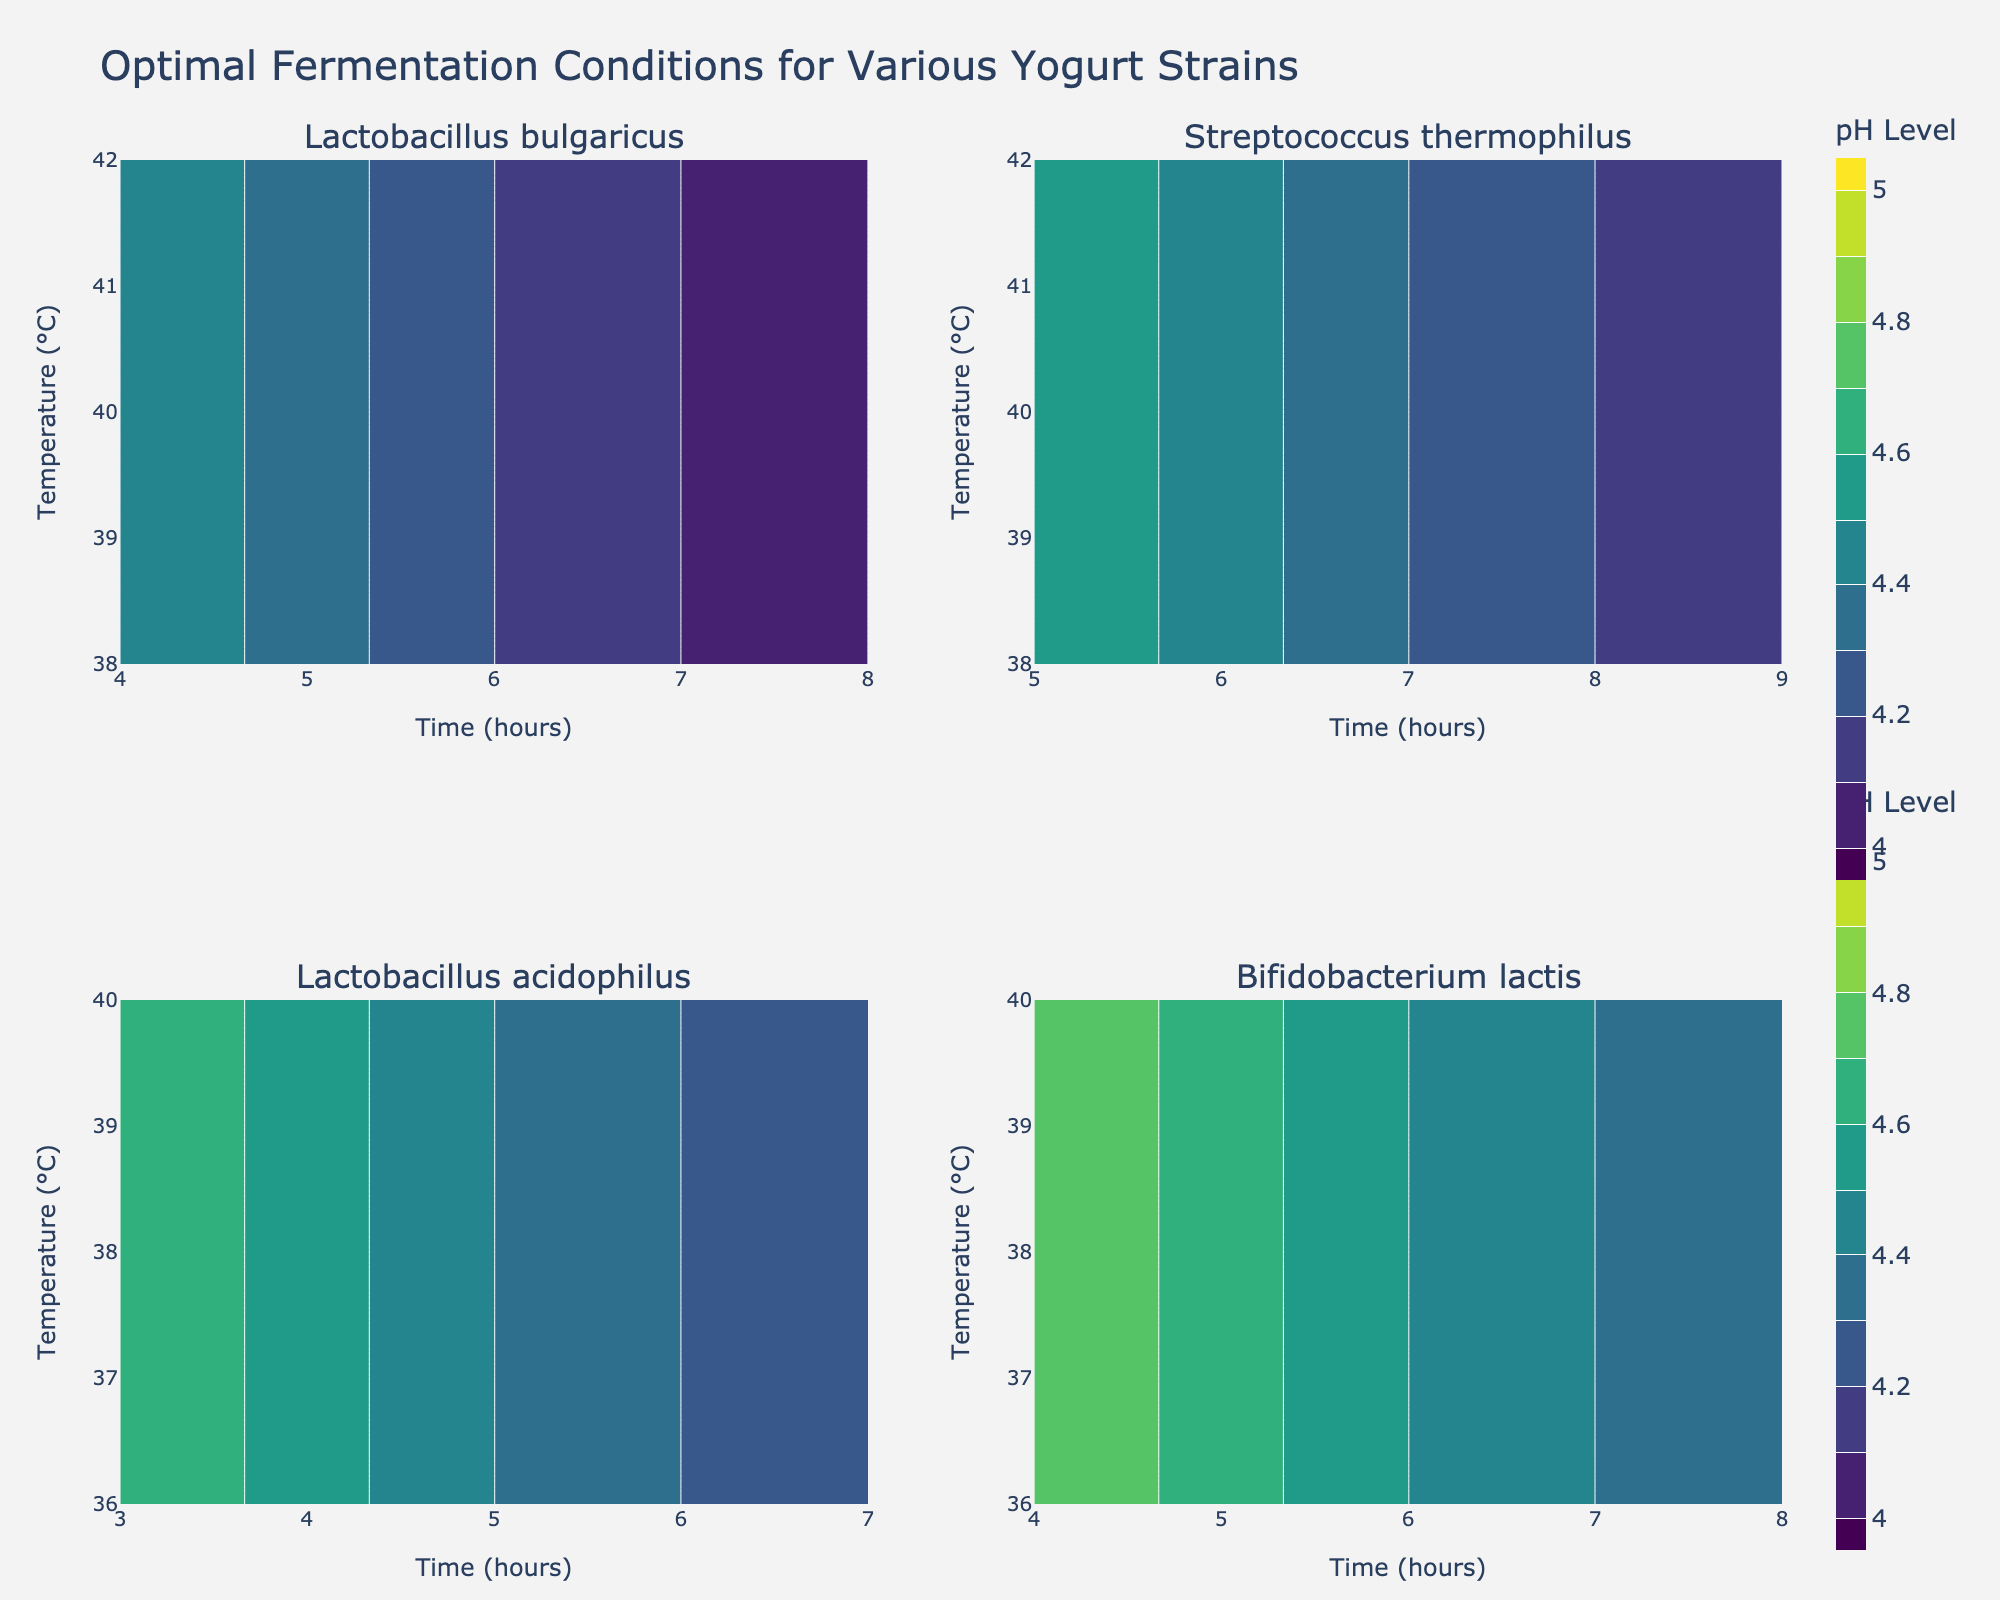What is the title of the figure? The title is displayed at the top center of the figure, indicating the main topic covered by the visualization.
Answer: Optimal Fermentation Conditions for Various Yogurt Strains What are the strains of yogurt shown in the subplots? The strain names can be found in the subplot titles. By looking at each of the four subplots, we can see the strains listed.
Answer: Lactobacillus bulgaricus, Streptococcus thermophilus, Lactobacillus acidophilus, Bifidobacterium lactis What is the x-axis label for each subplot? The x-axis labels are displayed horizontally below each subplot. They help provide context for what the horizontal axis represents.
Answer: Time (hours) What is the y-axis label for each subplot? The y-axis labels are displayed vertically on the left side of each subplot. They help provide context for what the vertical axis represents.
Answer: Temperature (°C) Which strain requires the highest temperature for fermentation? By observing the contour plots and noting the upper range of temperatures on the y-axis, we can identify which strain has the highest temperature value.
Answer: Bifidobacterium lactis At what time and temperature does Lactobacillus bulgaricus achieve its lowest pH level? For Lactobacillus bulgaricus, look at the subplot and find the combination of time and temperature where the pH is lowest, as indicated by the contour plot.
Answer: 42°C and 8 hours Comparing Streptococcus thermophilus and Lactobacillus acidophilus, which strain maintains a lower pH level at 38°C? By examining the contour at 38°C within the subplots for these strains, we can compare their corresponding pH levels.
Answer: Streptococcus thermophilus What is the range of temperatures tested for Bifidobacterium lactis? Look at the y-axis labels of the subplot for Bifidobacterium lactis to determine the minimum and maximum temperature values tested.
Answer: 36°C to 40°C Which strain shows the largest variation in pH levels across different fermentation conditions? By comparing the contours in each subplot, identify the strain with the widest range of pH values.
Answer: Lactobacillus bulgaricus At 6 hours of fermentation time, which strain has the highest pH level? Locate the 6-hour mark on the x-axis for each subplot and observe the corresponding pH levels to identify the highest value.
Answer: Bifidobacterium lactis 